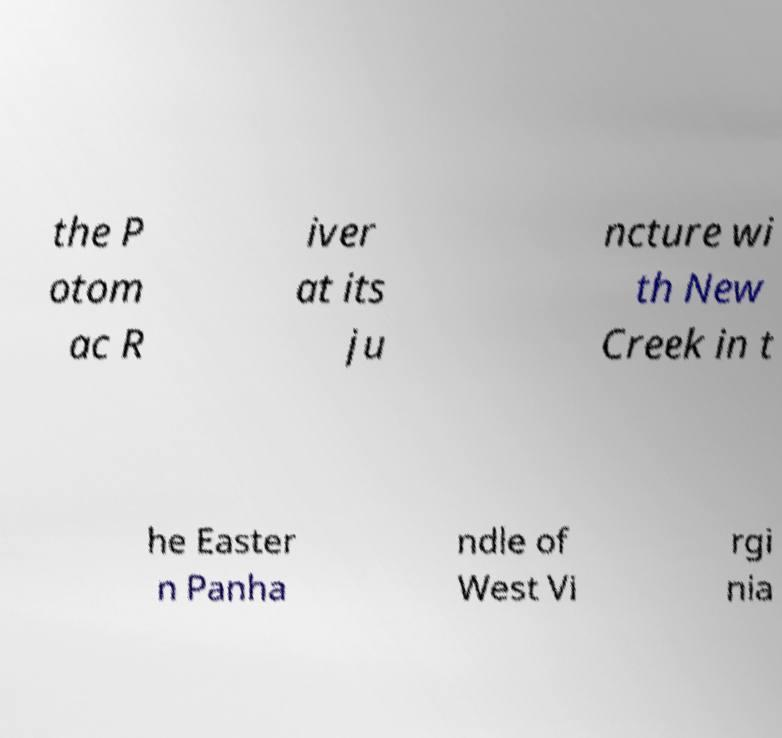Could you assist in decoding the text presented in this image and type it out clearly? the P otom ac R iver at its ju ncture wi th New Creek in t he Easter n Panha ndle of West Vi rgi nia 